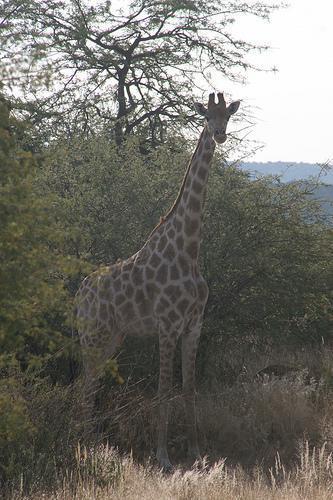How many animals are visible in the picture?
Give a very brief answer. 1. 